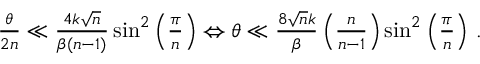<formula> <loc_0><loc_0><loc_500><loc_500>\begin{array} { r } { \frac { \theta } { 2 n } \ll \frac { 4 k \sqrt { n } } { \beta ( n - 1 ) } \sin ^ { 2 } \left ( \frac { \pi } { n } \right ) \Leftrightarrow \theta \ll \frac { 8 \sqrt { n } k } { \beta } \left ( \frac { n } { n - 1 } \right ) \sin ^ { 2 } \left ( \frac { \pi } { n } \right ) \, . } \end{array}</formula> 